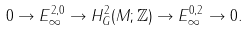<formula> <loc_0><loc_0><loc_500><loc_500>0 \rightarrow E _ { \infty } ^ { 2 , 0 } \rightarrow H ^ { 2 } _ { G } ( M ; \mathbb { Z } ) \rightarrow E _ { \infty } ^ { 0 , 2 } \rightarrow 0 .</formula> 